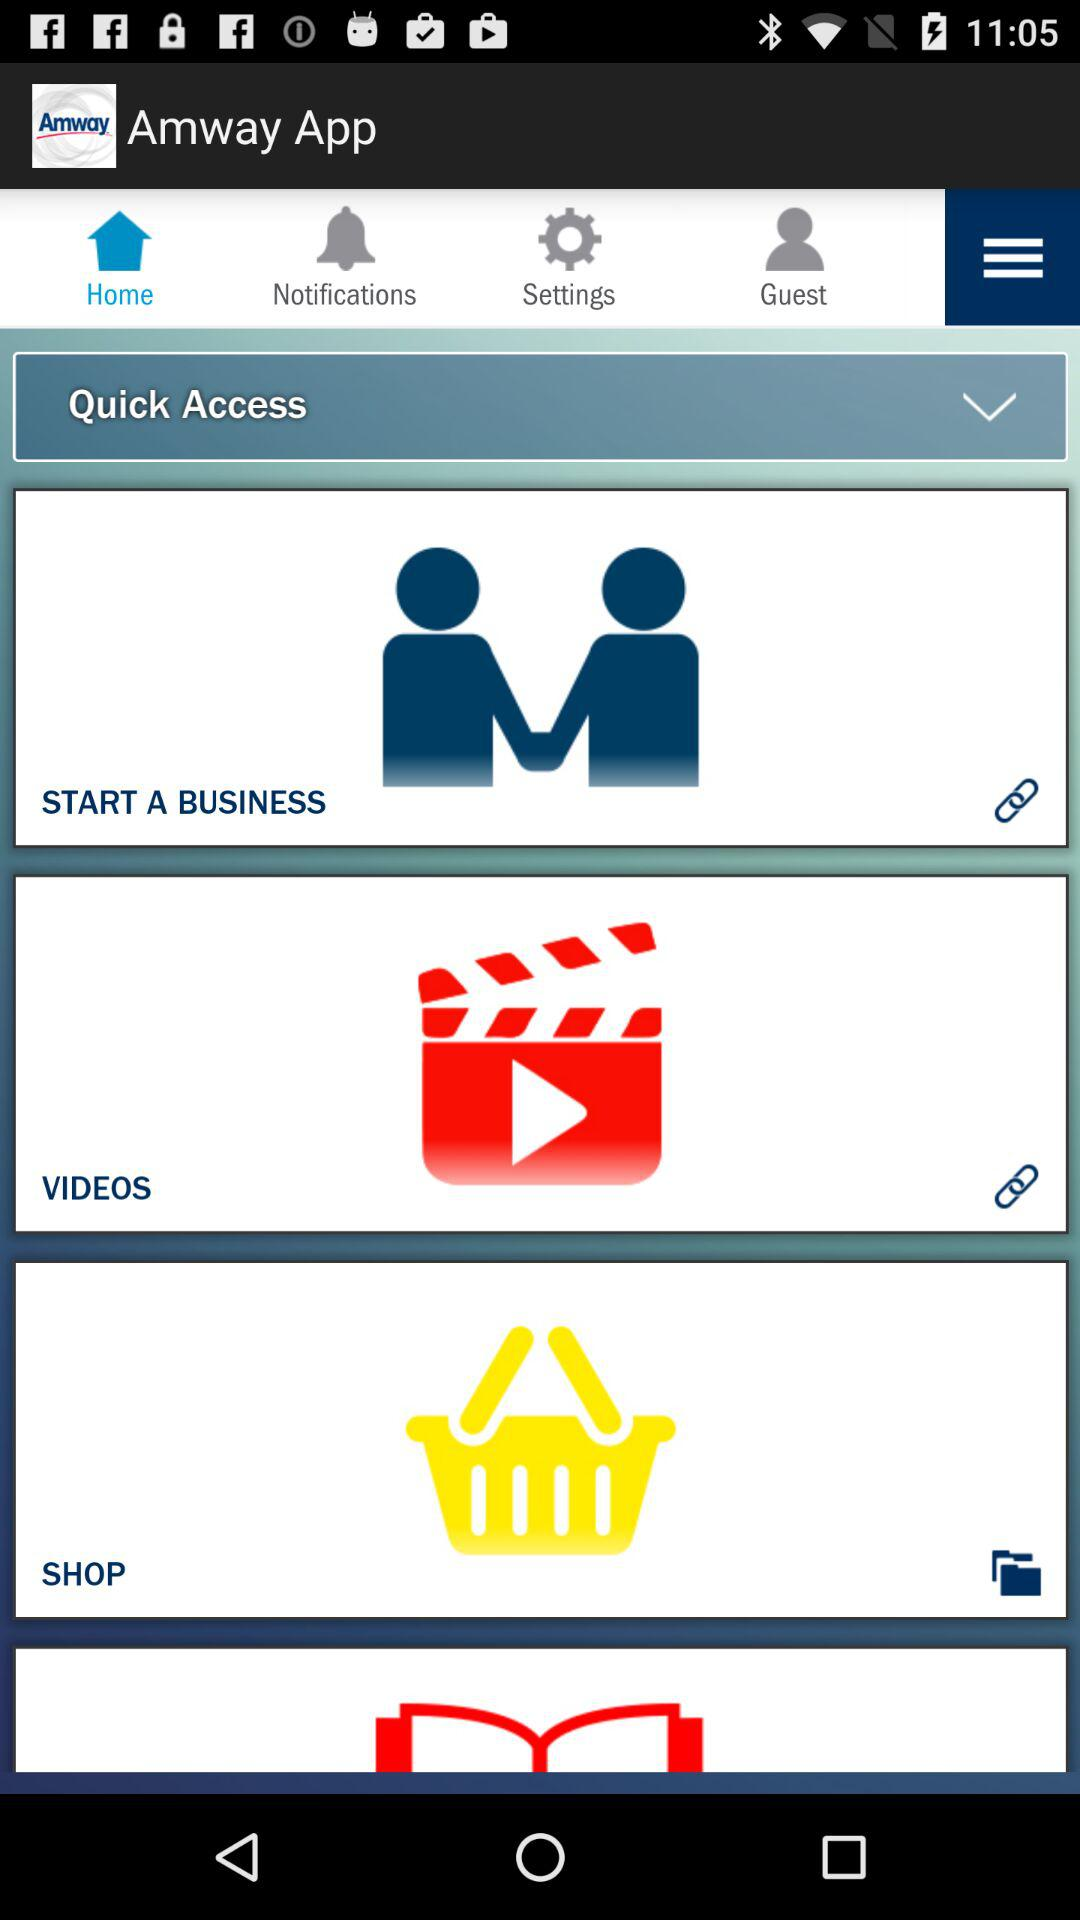What is the application name? The application name is "Amway App". 